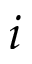Convert formula to latex. <formula><loc_0><loc_0><loc_500><loc_500>i</formula> 